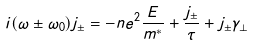Convert formula to latex. <formula><loc_0><loc_0><loc_500><loc_500>i ( \omega \pm \omega _ { 0 } ) j _ { \pm } = - n e ^ { 2 } \frac { E } { m ^ { * } } + \frac { j _ { \pm } } { \tau } + j _ { \pm } \gamma _ { \bot }</formula> 